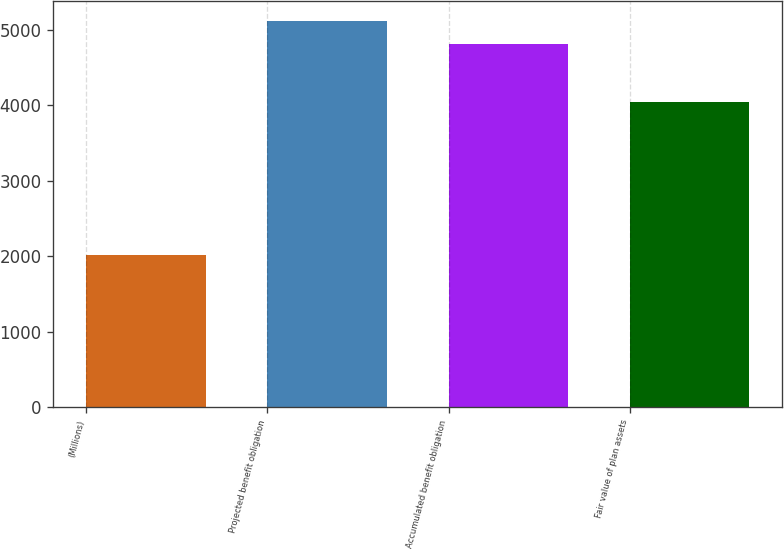<chart> <loc_0><loc_0><loc_500><loc_500><bar_chart><fcel>(Millions)<fcel>Projected benefit obligation<fcel>Accumulated benefit obligation<fcel>Fair value of plan assets<nl><fcel>2012<fcel>5122<fcel>4808<fcel>4038<nl></chart> 